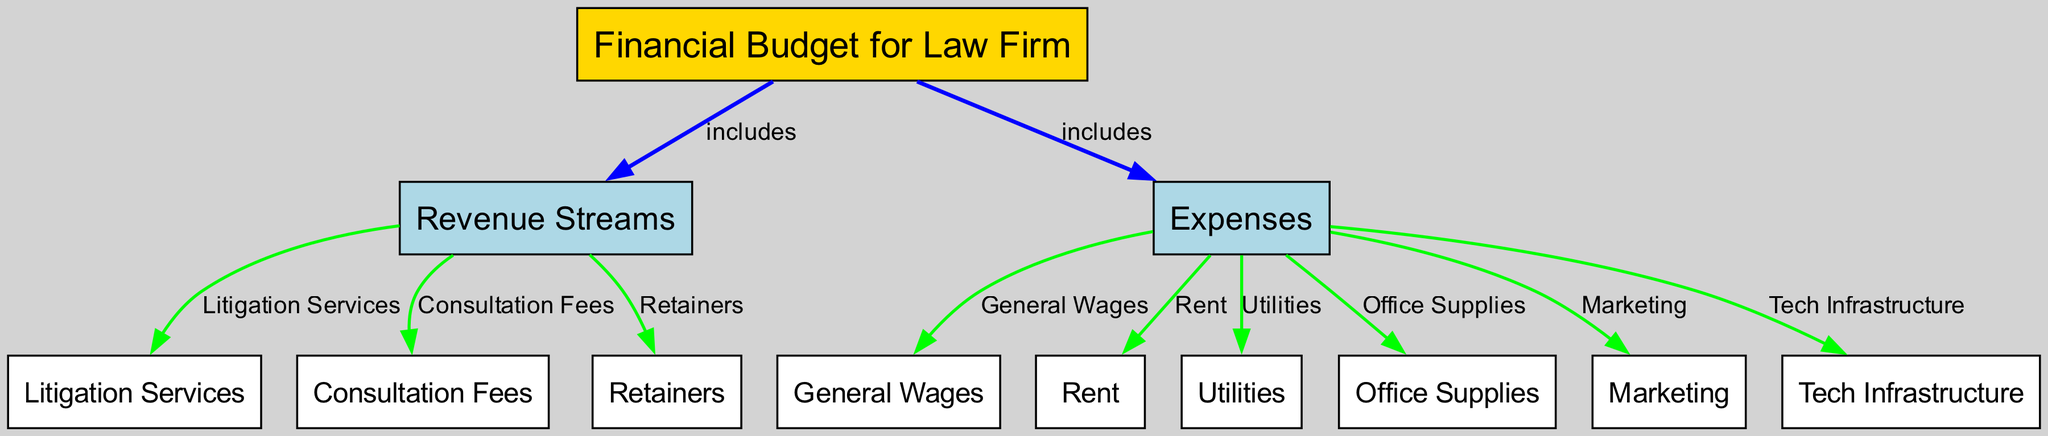What are the two main categories included in the financial budget? The diagram shows two main categories under the financial budget: Revenue Streams and Expenses. Both categories are directly connected to the main node labeled "Financial Budget for Law Firm."
Answer: Revenue Streams and Expenses How many revenue streams are represented in the diagram? The diagram indicates three distinct revenue streams connected to the "Revenue Streams" node, which are Litigation Services, Consultation Fees, and Retainers.
Answer: Three What type of expense is 'Rent'? 'Rent' is categorized under the node labeled 'Expenses.' It is one of several different expenses incurred by the law firm, specifically categorized as an operational expense necessary for maintaining office space.
Answer: Operational expense Which node is connected to the 'Expenses' node with a green edge? The node 'General Wages' is connected to 'Expenses' with a green edge, indicating it is a type of expense incurred by the firm, represented in the flow of expenses from the general category.
Answer: General Wages How many connections does the 'Litigation Services' node have? The 'Litigation Services' node has one direct connection to the 'Revenue Streams' node, indicating that it is a single revenue stream for the law firm.
Answer: One What color is the 'Financial Budget for Law Firm' node? The 'Financial Budget for Law Firm' node is colored gold, distinguishing it as the central node of the diagram.
Answer: Gold Which type of expense is associated with 'Marketing'? 'Marketing' falls under the category of 'Expenses' as indicated on the diagram, specifically categorized as a promotional expense aimed at attracting clients.
Answer: Promotional expense What indicates the relationship between 'Revenue Streams' and 'Expenses'? The diagram shows that both 'Revenue Streams' and 'Expenses' are directly linked to the 'Financial Budget for Law Firm,' indicating they are both crucial components of the overall financial structure of the law firm.
Answer: Included in the budget How many total nodes are present in the diagram? The diagram consists of a total of twelve nodes, including categories and individual revenue and expense types outlined under each section.
Answer: Twelve 